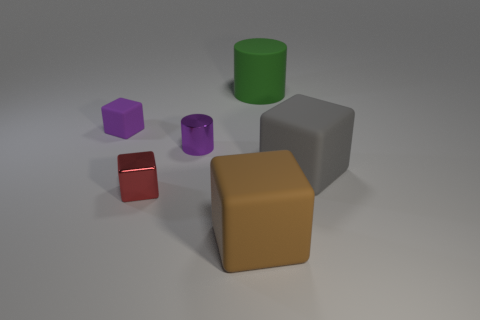What is the gray cube made of?
Your answer should be compact. Rubber. There is a purple rubber cube; how many things are in front of it?
Your answer should be very brief. 4. Do the tiny matte object and the tiny metallic cylinder have the same color?
Offer a terse response. Yes. How many small matte things are the same color as the tiny cylinder?
Your answer should be very brief. 1. Are there more green objects than yellow rubber things?
Ensure brevity in your answer.  Yes. There is a matte block that is behind the small shiny cube and right of the red metallic cube; what is its size?
Provide a succinct answer. Large. Is the material of the purple object to the left of the purple metallic thing the same as the large block that is behind the tiny red cube?
Ensure brevity in your answer.  Yes. There is a gray rubber thing that is the same size as the brown thing; what shape is it?
Provide a succinct answer. Cube. Are there fewer matte blocks than objects?
Provide a short and direct response. Yes. Are there any things that are on the left side of the big thing left of the green thing?
Your answer should be very brief. Yes. 